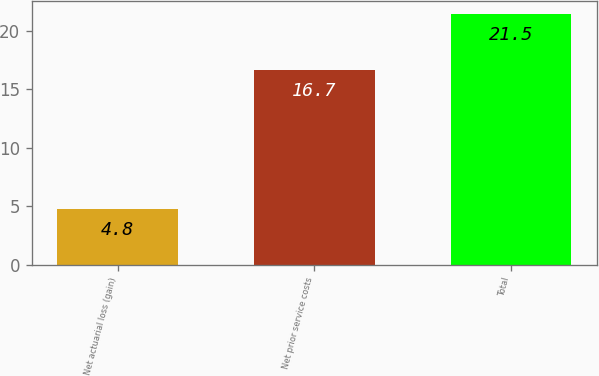Convert chart to OTSL. <chart><loc_0><loc_0><loc_500><loc_500><bar_chart><fcel>Net actuarial loss (gain)<fcel>Net prior service costs<fcel>Total<nl><fcel>4.8<fcel>16.7<fcel>21.5<nl></chart> 